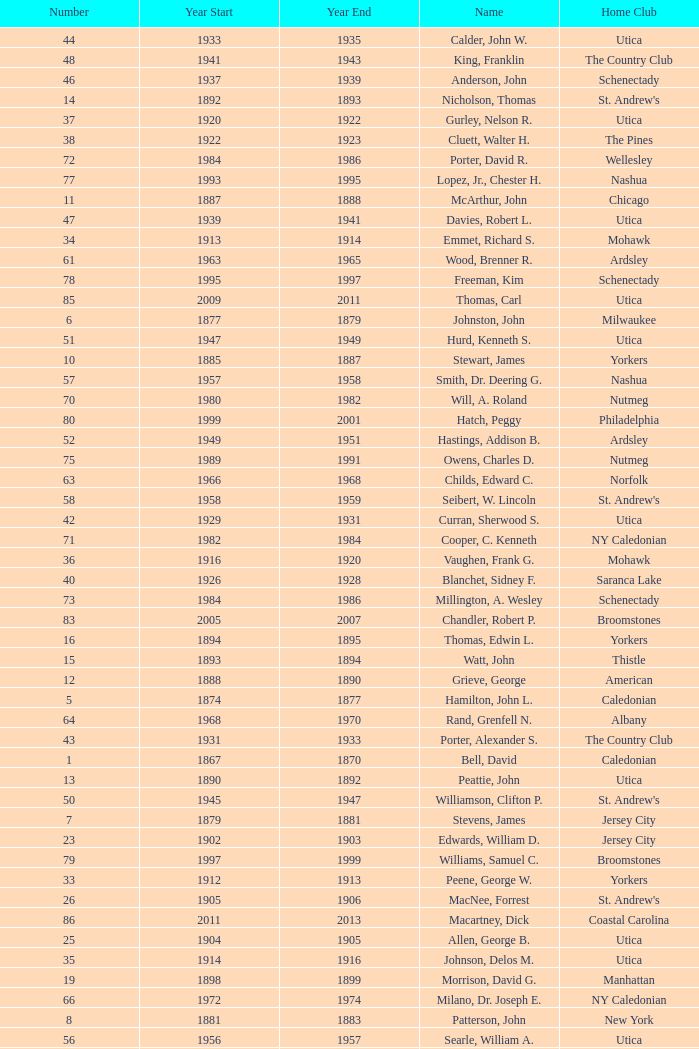Can you parse all the data within this table? {'header': ['Number', 'Year Start', 'Year End', 'Name', 'Home Club'], 'rows': [['44', '1933', '1935', 'Calder, John W.', 'Utica'], ['48', '1941', '1943', 'King, Franklin', 'The Country Club'], ['46', '1937', '1939', 'Anderson, John', 'Schenectady'], ['14', '1892', '1893', 'Nicholson, Thomas', "St. Andrew's"], ['37', '1920', '1922', 'Gurley, Nelson R.', 'Utica'], ['38', '1922', '1923', 'Cluett, Walter H.', 'The Pines'], ['72', '1984', '1986', 'Porter, David R.', 'Wellesley'], ['77', '1993', '1995', 'Lopez, Jr., Chester H.', 'Nashua'], ['11', '1887', '1888', 'McArthur, John', 'Chicago'], ['47', '1939', '1941', 'Davies, Robert L.', 'Utica'], ['34', '1913', '1914', 'Emmet, Richard S.', 'Mohawk'], ['61', '1963', '1965', 'Wood, Brenner R.', 'Ardsley'], ['78', '1995', '1997', 'Freeman, Kim', 'Schenectady'], ['85', '2009', '2011', 'Thomas, Carl', 'Utica'], ['6', '1877', '1879', 'Johnston, John', 'Milwaukee'], ['51', '1947', '1949', 'Hurd, Kenneth S.', 'Utica'], ['10', '1885', '1887', 'Stewart, James', 'Yorkers'], ['57', '1957', '1958', 'Smith, Dr. Deering G.', 'Nashua'], ['70', '1980', '1982', 'Will, A. Roland', 'Nutmeg'], ['80', '1999', '2001', 'Hatch, Peggy', 'Philadelphia'], ['52', '1949', '1951', 'Hastings, Addison B.', 'Ardsley'], ['75', '1989', '1991', 'Owens, Charles D.', 'Nutmeg'], ['63', '1966', '1968', 'Childs, Edward C.', 'Norfolk'], ['58', '1958', '1959', 'Seibert, W. Lincoln', "St. Andrew's"], ['42', '1929', '1931', 'Curran, Sherwood S.', 'Utica'], ['71', '1982', '1984', 'Cooper, C. Kenneth', 'NY Caledonian'], ['36', '1916', '1920', 'Vaughen, Frank G.', 'Mohawk'], ['40', '1926', '1928', 'Blanchet, Sidney F.', 'Saranca Lake'], ['73', '1984', '1986', 'Millington, A. Wesley', 'Schenectady'], ['83', '2005', '2007', 'Chandler, Robert P.', 'Broomstones'], ['16', '1894', '1895', 'Thomas, Edwin L.', 'Yorkers'], ['15', '1893', '1894', 'Watt, John', 'Thistle'], ['12', '1888', '1890', 'Grieve, George', 'American'], ['5', '1874', '1877', 'Hamilton, John L.', 'Caledonian'], ['64', '1968', '1970', 'Rand, Grenfell N.', 'Albany'], ['43', '1931', '1933', 'Porter, Alexander S.', 'The Country Club'], ['1', '1867', '1870', 'Bell, David', 'Caledonian'], ['13', '1890', '1892', 'Peattie, John', 'Utica'], ['50', '1945', '1947', 'Williamson, Clifton P.', "St. Andrew's"], ['7', '1879', '1881', 'Stevens, James', 'Jersey City'], ['23', '1902', '1903', 'Edwards, William D.', 'Jersey City'], ['79', '1997', '1999', 'Williams, Samuel C.', 'Broomstones'], ['33', '1912', '1913', 'Peene, George W.', 'Yorkers'], ['26', '1905', '1906', 'MacNee, Forrest', "St. Andrew's"], ['86', '2011', '2013', 'Macartney, Dick', 'Coastal Carolina'], ['25', '1904', '1905', 'Allen, George B.', 'Utica'], ['35', '1914', '1916', 'Johnson, Delos M.', 'Utica'], ['19', '1898', '1899', 'Morrison, David G.', 'Manhattan'], ['66', '1972', '1974', 'Milano, Dr. Joseph E.', 'NY Caledonian'], ['8', '1881', '1883', 'Patterson, John', 'New York'], ['56', '1956', '1957', 'Searle, William A.', 'Utica'], ['68', '1976', '1978', 'Cobb, Arthur J.', 'Utica'], ['41', '1928', '1929', 'Halliday, Alexander B.', "St. Andrew's"], ['30', '1909', '1910', 'Allen, W. Fred', 'Utica'], ['27', '1906', '1907', 'Johnson, Herman I.', 'Utica'], ['45', '1935', '1937', 'Patterson, Jr., C. Campbell', 'The Country Club'], ['59', '1959', '1961', 'Reid, Ralston B.', 'Schenectady'], ['29', '1908', '1909', 'Watt, Thomas J.', 'Thistle'], ['62', '1965', '1966', 'Parkinson, Fred E.', 'Utica'], ['21', '1900', '1901', 'Conley, James F.', 'Empire City'], ['76', '1991', '1993', 'Mitchell, J. Peter', 'Garden State'], ['32', '1911', '1912', 'Calder, Frederick M.', 'Utica'], ['2', '1870', '1872', 'Dalrymple, Alexander', "St. Andrew's"], ['69', '1978', '1980', 'Hamm, Arthur E.', 'Petersham'], ['49', '1943', '1945', 'Lydgate, Theodore H.', 'Schenectady'], ['17', '1895', '1897', 'McCulloch, John', 'St. Paul'], ['54', '1953', '1954', 'Davis, Richard P.', 'Schenectady'], ['9', '1883', '1885', 'McLaren, William P.', 'Milwaukee'], ['3', '1872', '1873', 'Macnoe, George', 'Caledonian'], ['24', '1903', '1904', 'Thaw, James', 'Thistle'], ['84', '2007', '2009', 'Krailo, Gwen', 'Nashua'], ['67', '1974', '1976', 'Neuber, Dr. Richard A.', 'Schenectady'], ['20', '1899', '1900', 'McGaw, John', 'Boston'], ['74', '1988', '1989', 'Dewees, Dr. David C.', 'Cape Cod'], ['18', '1897', '1898', 'Thompson, Alexander', 'United'], ['4', '1873', '1874', 'Hoagland, Andrew', "St. Andrew's"], ['82', '2003', '2005', 'Pelletier, Robert', 'Potomac'], ['55', '1954', '1956', 'Joy, John H.', 'Winchester'], ['60', '1961', '1963', 'Cushing, Henry K.', 'The Country Club'], ['65', '1970', '1972', 'Neill, Stanley E.', 'Winchester'], ['31', '1910', '1911', 'Archibald, Henry', 'Caledonian'], ['28', '1907', '1908', 'Lehmann, John A.', 'Empire'], ['22', '1901', '1902', 'Munson, Alfred H.', 'Utica'], ['81', '2001', '2003', 'Garber, Thomas', 'Utica'], ['53', '1951', '1953', 'Hill, Lucius T.', 'The Country Club'], ['39', '1923', '1926', 'Farrell, Thomas H.', 'Utica']]} Which Number has a Home Club of broomstones, and a Year End smaller than 1999? None. 